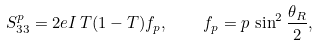Convert formula to latex. <formula><loc_0><loc_0><loc_500><loc_500>S _ { 3 3 } ^ { p } = 2 e I \, T ( 1 - T ) f _ { p } , \quad f _ { p } = p \, \sin ^ { 2 } \frac { \theta _ { R } } { 2 } ,</formula> 